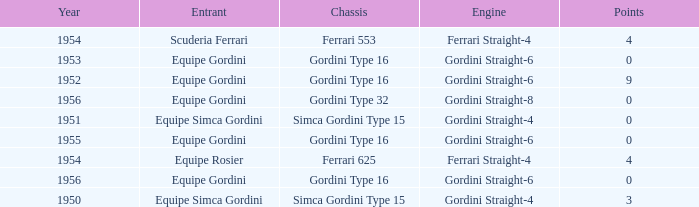What engine was used by Equipe Simca Gordini before 1956 with less than 4 points? Gordini Straight-4, Gordini Straight-4. 